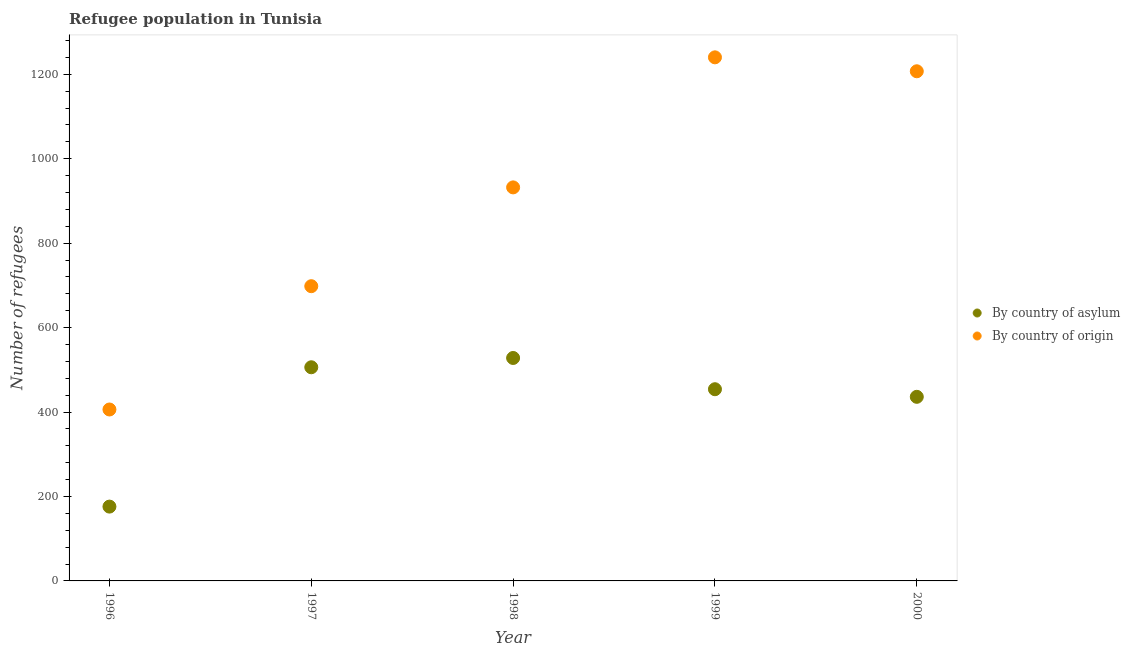Is the number of dotlines equal to the number of legend labels?
Your answer should be compact. Yes. What is the number of refugees by country of origin in 2000?
Keep it short and to the point. 1207. Across all years, what is the maximum number of refugees by country of origin?
Your response must be concise. 1240. Across all years, what is the minimum number of refugees by country of origin?
Offer a terse response. 406. In which year was the number of refugees by country of origin minimum?
Make the answer very short. 1996. What is the total number of refugees by country of origin in the graph?
Provide a succinct answer. 4483. What is the difference between the number of refugees by country of asylum in 1997 and that in 1998?
Make the answer very short. -22. What is the difference between the number of refugees by country of origin in 1997 and the number of refugees by country of asylum in 1996?
Your response must be concise. 522. What is the average number of refugees by country of origin per year?
Give a very brief answer. 896.6. In the year 1999, what is the difference between the number of refugees by country of asylum and number of refugees by country of origin?
Your answer should be very brief. -786. What is the ratio of the number of refugees by country of origin in 1999 to that in 2000?
Ensure brevity in your answer.  1.03. Is the number of refugees by country of asylum in 1996 less than that in 1998?
Make the answer very short. Yes. What is the difference between the highest and the second highest number of refugees by country of asylum?
Ensure brevity in your answer.  22. What is the difference between the highest and the lowest number of refugees by country of asylum?
Provide a succinct answer. 352. In how many years, is the number of refugees by country of origin greater than the average number of refugees by country of origin taken over all years?
Offer a very short reply. 3. How many years are there in the graph?
Your answer should be compact. 5. What is the difference between two consecutive major ticks on the Y-axis?
Ensure brevity in your answer.  200. Are the values on the major ticks of Y-axis written in scientific E-notation?
Offer a terse response. No. Where does the legend appear in the graph?
Keep it short and to the point. Center right. How many legend labels are there?
Give a very brief answer. 2. What is the title of the graph?
Offer a very short reply. Refugee population in Tunisia. What is the label or title of the Y-axis?
Offer a very short reply. Number of refugees. What is the Number of refugees in By country of asylum in 1996?
Your answer should be compact. 176. What is the Number of refugees of By country of origin in 1996?
Your answer should be very brief. 406. What is the Number of refugees of By country of asylum in 1997?
Offer a terse response. 506. What is the Number of refugees of By country of origin in 1997?
Offer a terse response. 698. What is the Number of refugees of By country of asylum in 1998?
Ensure brevity in your answer.  528. What is the Number of refugees of By country of origin in 1998?
Provide a succinct answer. 932. What is the Number of refugees of By country of asylum in 1999?
Your answer should be compact. 454. What is the Number of refugees of By country of origin in 1999?
Your answer should be very brief. 1240. What is the Number of refugees in By country of asylum in 2000?
Give a very brief answer. 436. What is the Number of refugees of By country of origin in 2000?
Your answer should be compact. 1207. Across all years, what is the maximum Number of refugees of By country of asylum?
Provide a succinct answer. 528. Across all years, what is the maximum Number of refugees in By country of origin?
Provide a succinct answer. 1240. Across all years, what is the minimum Number of refugees of By country of asylum?
Provide a succinct answer. 176. Across all years, what is the minimum Number of refugees of By country of origin?
Your answer should be compact. 406. What is the total Number of refugees of By country of asylum in the graph?
Make the answer very short. 2100. What is the total Number of refugees in By country of origin in the graph?
Give a very brief answer. 4483. What is the difference between the Number of refugees of By country of asylum in 1996 and that in 1997?
Provide a short and direct response. -330. What is the difference between the Number of refugees of By country of origin in 1996 and that in 1997?
Provide a short and direct response. -292. What is the difference between the Number of refugees of By country of asylum in 1996 and that in 1998?
Provide a short and direct response. -352. What is the difference between the Number of refugees in By country of origin in 1996 and that in 1998?
Make the answer very short. -526. What is the difference between the Number of refugees in By country of asylum in 1996 and that in 1999?
Give a very brief answer. -278. What is the difference between the Number of refugees of By country of origin in 1996 and that in 1999?
Provide a short and direct response. -834. What is the difference between the Number of refugees of By country of asylum in 1996 and that in 2000?
Provide a succinct answer. -260. What is the difference between the Number of refugees of By country of origin in 1996 and that in 2000?
Ensure brevity in your answer.  -801. What is the difference between the Number of refugees in By country of origin in 1997 and that in 1998?
Provide a succinct answer. -234. What is the difference between the Number of refugees of By country of origin in 1997 and that in 1999?
Make the answer very short. -542. What is the difference between the Number of refugees in By country of asylum in 1997 and that in 2000?
Provide a short and direct response. 70. What is the difference between the Number of refugees of By country of origin in 1997 and that in 2000?
Keep it short and to the point. -509. What is the difference between the Number of refugees in By country of asylum in 1998 and that in 1999?
Offer a very short reply. 74. What is the difference between the Number of refugees in By country of origin in 1998 and that in 1999?
Offer a terse response. -308. What is the difference between the Number of refugees in By country of asylum in 1998 and that in 2000?
Ensure brevity in your answer.  92. What is the difference between the Number of refugees in By country of origin in 1998 and that in 2000?
Your response must be concise. -275. What is the difference between the Number of refugees of By country of asylum in 1999 and that in 2000?
Offer a terse response. 18. What is the difference between the Number of refugees of By country of origin in 1999 and that in 2000?
Provide a succinct answer. 33. What is the difference between the Number of refugees in By country of asylum in 1996 and the Number of refugees in By country of origin in 1997?
Make the answer very short. -522. What is the difference between the Number of refugees in By country of asylum in 1996 and the Number of refugees in By country of origin in 1998?
Your response must be concise. -756. What is the difference between the Number of refugees in By country of asylum in 1996 and the Number of refugees in By country of origin in 1999?
Provide a succinct answer. -1064. What is the difference between the Number of refugees of By country of asylum in 1996 and the Number of refugees of By country of origin in 2000?
Keep it short and to the point. -1031. What is the difference between the Number of refugees of By country of asylum in 1997 and the Number of refugees of By country of origin in 1998?
Provide a short and direct response. -426. What is the difference between the Number of refugees in By country of asylum in 1997 and the Number of refugees in By country of origin in 1999?
Ensure brevity in your answer.  -734. What is the difference between the Number of refugees in By country of asylum in 1997 and the Number of refugees in By country of origin in 2000?
Make the answer very short. -701. What is the difference between the Number of refugees of By country of asylum in 1998 and the Number of refugees of By country of origin in 1999?
Your response must be concise. -712. What is the difference between the Number of refugees in By country of asylum in 1998 and the Number of refugees in By country of origin in 2000?
Offer a terse response. -679. What is the difference between the Number of refugees of By country of asylum in 1999 and the Number of refugees of By country of origin in 2000?
Your answer should be compact. -753. What is the average Number of refugees in By country of asylum per year?
Your response must be concise. 420. What is the average Number of refugees of By country of origin per year?
Your answer should be compact. 896.6. In the year 1996, what is the difference between the Number of refugees of By country of asylum and Number of refugees of By country of origin?
Your answer should be compact. -230. In the year 1997, what is the difference between the Number of refugees in By country of asylum and Number of refugees in By country of origin?
Keep it short and to the point. -192. In the year 1998, what is the difference between the Number of refugees in By country of asylum and Number of refugees in By country of origin?
Provide a succinct answer. -404. In the year 1999, what is the difference between the Number of refugees of By country of asylum and Number of refugees of By country of origin?
Offer a terse response. -786. In the year 2000, what is the difference between the Number of refugees of By country of asylum and Number of refugees of By country of origin?
Provide a succinct answer. -771. What is the ratio of the Number of refugees of By country of asylum in 1996 to that in 1997?
Your answer should be compact. 0.35. What is the ratio of the Number of refugees in By country of origin in 1996 to that in 1997?
Offer a terse response. 0.58. What is the ratio of the Number of refugees in By country of origin in 1996 to that in 1998?
Ensure brevity in your answer.  0.44. What is the ratio of the Number of refugees in By country of asylum in 1996 to that in 1999?
Keep it short and to the point. 0.39. What is the ratio of the Number of refugees of By country of origin in 1996 to that in 1999?
Your answer should be very brief. 0.33. What is the ratio of the Number of refugees of By country of asylum in 1996 to that in 2000?
Provide a succinct answer. 0.4. What is the ratio of the Number of refugees in By country of origin in 1996 to that in 2000?
Ensure brevity in your answer.  0.34. What is the ratio of the Number of refugees of By country of origin in 1997 to that in 1998?
Provide a succinct answer. 0.75. What is the ratio of the Number of refugees of By country of asylum in 1997 to that in 1999?
Your answer should be compact. 1.11. What is the ratio of the Number of refugees of By country of origin in 1997 to that in 1999?
Keep it short and to the point. 0.56. What is the ratio of the Number of refugees in By country of asylum in 1997 to that in 2000?
Give a very brief answer. 1.16. What is the ratio of the Number of refugees of By country of origin in 1997 to that in 2000?
Give a very brief answer. 0.58. What is the ratio of the Number of refugees in By country of asylum in 1998 to that in 1999?
Your answer should be very brief. 1.16. What is the ratio of the Number of refugees of By country of origin in 1998 to that in 1999?
Provide a short and direct response. 0.75. What is the ratio of the Number of refugees in By country of asylum in 1998 to that in 2000?
Ensure brevity in your answer.  1.21. What is the ratio of the Number of refugees of By country of origin in 1998 to that in 2000?
Your answer should be very brief. 0.77. What is the ratio of the Number of refugees in By country of asylum in 1999 to that in 2000?
Your answer should be very brief. 1.04. What is the ratio of the Number of refugees in By country of origin in 1999 to that in 2000?
Ensure brevity in your answer.  1.03. What is the difference between the highest and the second highest Number of refugees of By country of origin?
Offer a very short reply. 33. What is the difference between the highest and the lowest Number of refugees of By country of asylum?
Your answer should be very brief. 352. What is the difference between the highest and the lowest Number of refugees in By country of origin?
Make the answer very short. 834. 